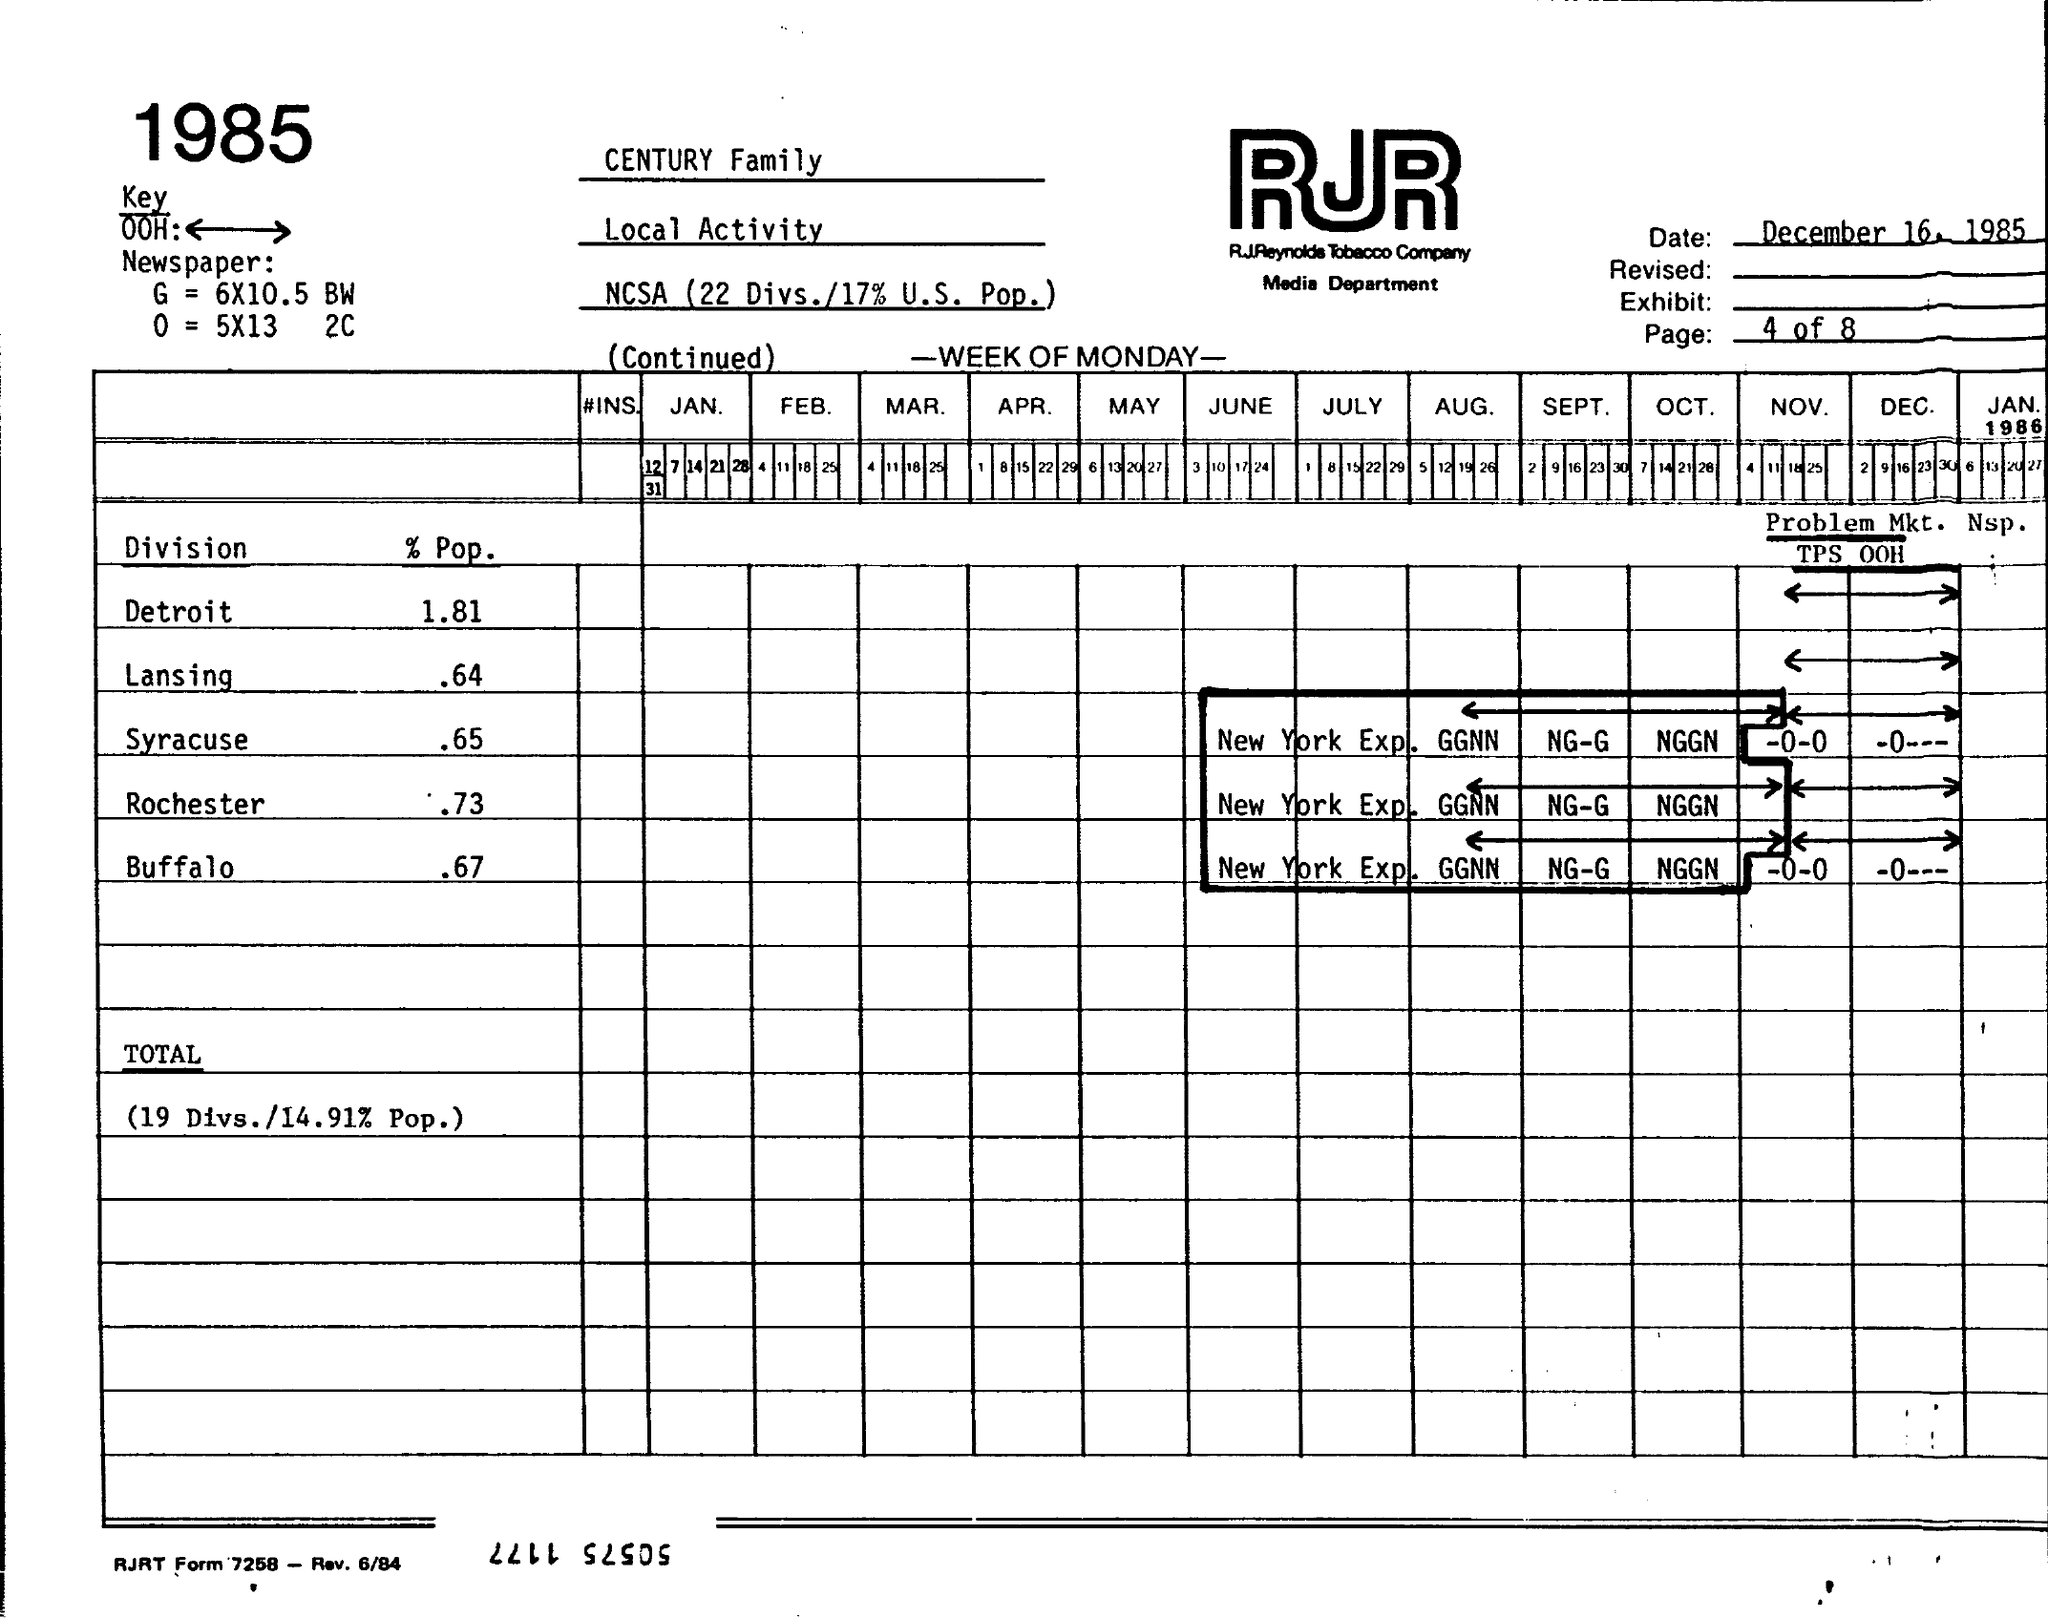What is the % Pop for Detroit? According to the document in the image, the percentage population (% Pop) for Detroit in 1985 was 1.81% within the specified context. 